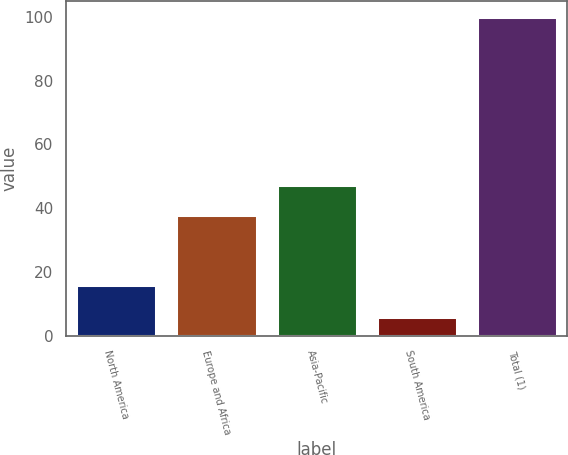Convert chart. <chart><loc_0><loc_0><loc_500><loc_500><bar_chart><fcel>North America<fcel>Europe and Africa<fcel>Asia-Pacific<fcel>South America<fcel>Total (1)<nl><fcel>16<fcel>38<fcel>47.4<fcel>6<fcel>100<nl></chart> 